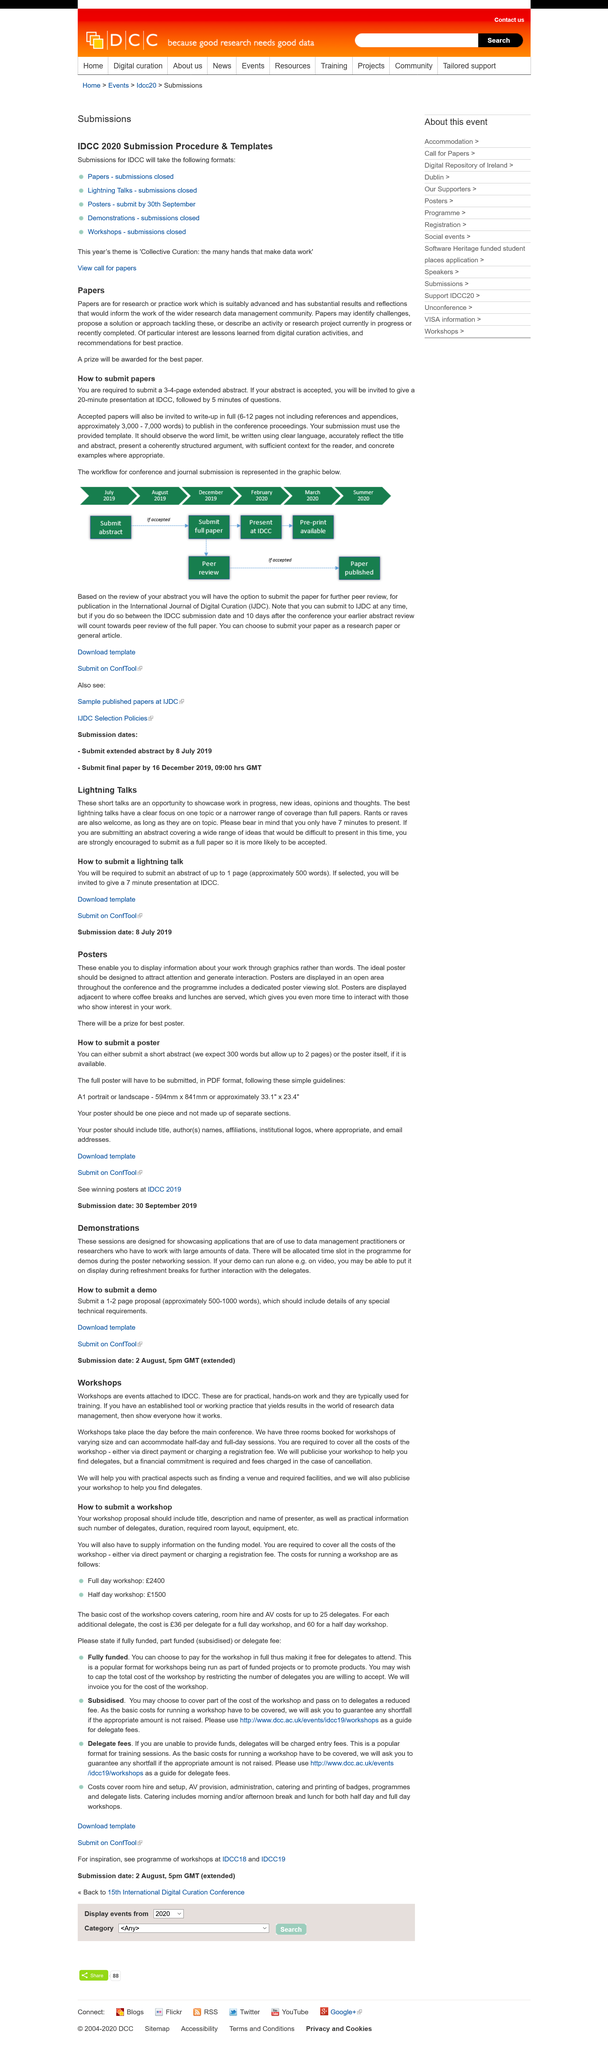Give some essential details in this illustration. After a successful review, if your abstract is accepted, you will be invited to present a 20-minute talk at IDCC, followed by a 5-minute question and answer session. You will receive a prize if you obtain the best poster. The word count for the proposal is approximately 500-1000 words. The posters will be displayed adjacent to the location where coffee breaks and lunches are served. It is necessary for the proposal to include details of any special technical requirements. 